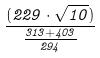Convert formula to latex. <formula><loc_0><loc_0><loc_500><loc_500>\frac { ( 2 2 9 \cdot \sqrt { 1 0 } ) } { \frac { 3 1 3 + 4 0 3 } { 2 9 4 } }</formula> 